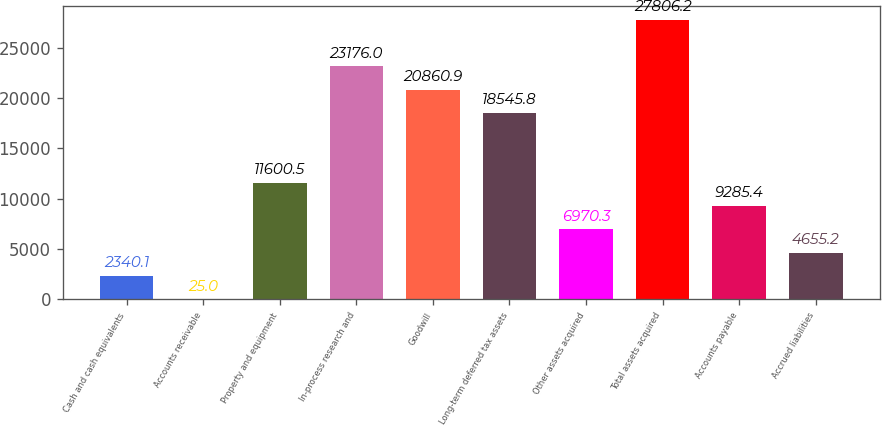<chart> <loc_0><loc_0><loc_500><loc_500><bar_chart><fcel>Cash and cash equivalents<fcel>Accounts receivable<fcel>Property and equipment<fcel>In-process research and<fcel>Goodwill<fcel>Long-term deferred tax assets<fcel>Other assets acquired<fcel>Total assets acquired<fcel>Accounts payable<fcel>Accrued liabilities<nl><fcel>2340.1<fcel>25<fcel>11600.5<fcel>23176<fcel>20860.9<fcel>18545.8<fcel>6970.3<fcel>27806.2<fcel>9285.4<fcel>4655.2<nl></chart> 